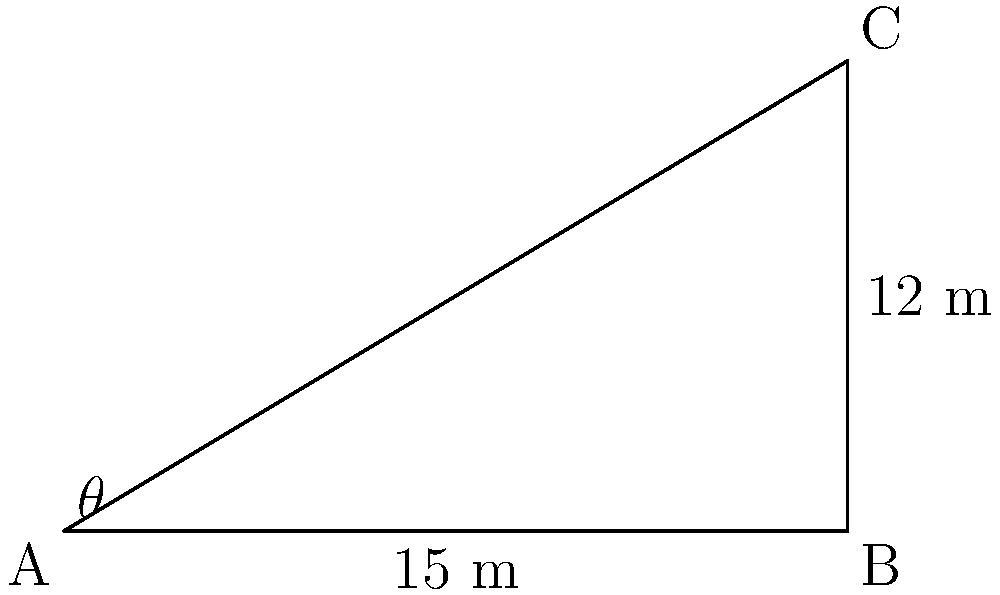In a modern theatre in Seoul, you're evaluating the visibility from different seats. From your position in the front row (point A), you observe that the top of the balcony (point C) is 12 meters above the floor and 15 meters away horizontally. What is the angle of elevation ($\theta$) from your eye level to the top of the balcony? Round your answer to the nearest degree. To solve this problem, we'll use trigonometry, specifically the tangent function. Let's approach this step-by-step:

1) We have a right triangle ABC, where:
   - A is your position
   - B is directly below the top of the balcony
   - C is the top of the balcony

2) We know:
   - The adjacent side (AB) = 15 meters
   - The opposite side (BC) = 12 meters

3) The tangent of an angle is defined as the ratio of the opposite side to the adjacent side:

   $\tan(\theta) = \frac{\text{opposite}}{\text{adjacent}} = \frac{BC}{AB}$

4) Substituting our known values:

   $\tan(\theta) = \frac{12}{15} = 0.8$

5) To find $\theta$, we need to use the inverse tangent (arctan or $\tan^{-1}$):

   $\theta = \tan^{-1}(0.8)$

6) Using a calculator or trigonometric tables:

   $\theta \approx 38.66°$

7) Rounding to the nearest degree:

   $\theta \approx 39°$
Answer: 39° 